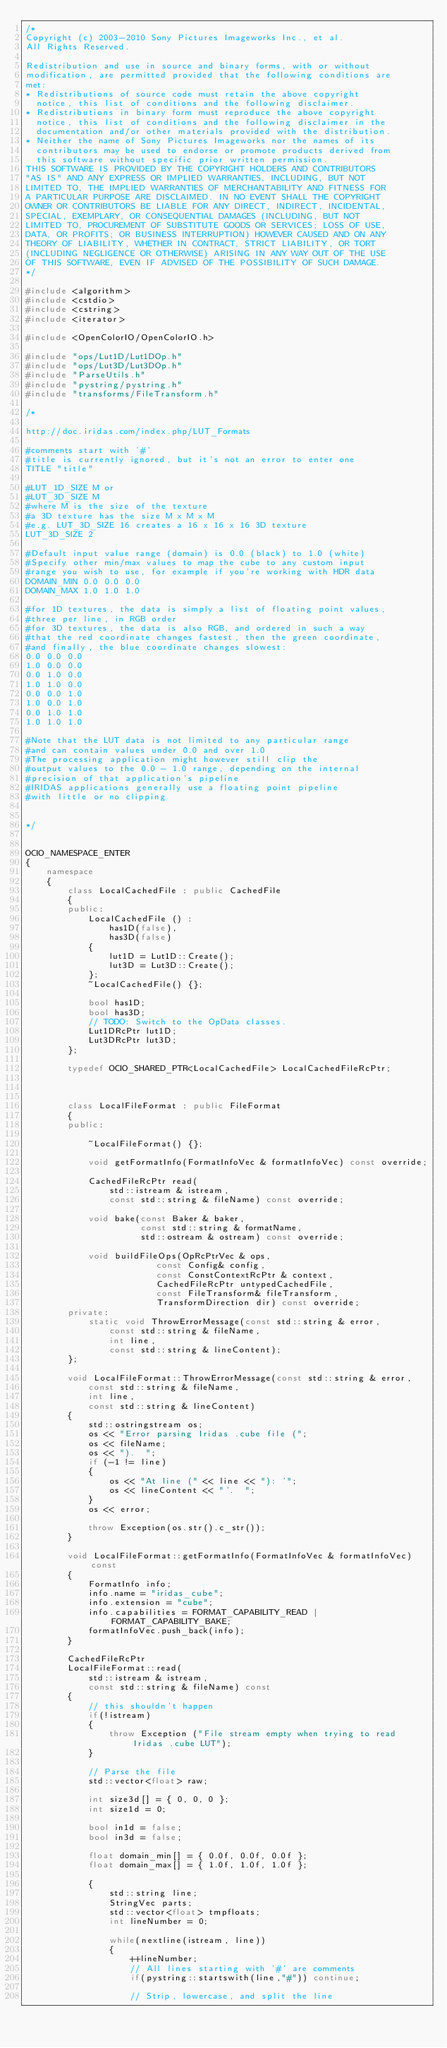<code> <loc_0><loc_0><loc_500><loc_500><_C++_>/*
Copyright (c) 2003-2010 Sony Pictures Imageworks Inc., et al.
All Rights Reserved.

Redistribution and use in source and binary forms, with or without
modification, are permitted provided that the following conditions are
met:
* Redistributions of source code must retain the above copyright
  notice, this list of conditions and the following disclaimer.
* Redistributions in binary form must reproduce the above copyright
  notice, this list of conditions and the following disclaimer in the
  documentation and/or other materials provided with the distribution.
* Neither the name of Sony Pictures Imageworks nor the names of its
  contributors may be used to endorse or promote products derived from
  this software without specific prior written permission.
THIS SOFTWARE IS PROVIDED BY THE COPYRIGHT HOLDERS AND CONTRIBUTORS
"AS IS" AND ANY EXPRESS OR IMPLIED WARRANTIES, INCLUDING, BUT NOT
LIMITED TO, THE IMPLIED WARRANTIES OF MERCHANTABILITY AND FITNESS FOR
A PARTICULAR PURPOSE ARE DISCLAIMED. IN NO EVENT SHALL THE COPYRIGHT
OWNER OR CONTRIBUTORS BE LIABLE FOR ANY DIRECT, INDIRECT, INCIDENTAL,
SPECIAL, EXEMPLARY, OR CONSEQUENTIAL DAMAGES (INCLUDING, BUT NOT
LIMITED TO, PROCUREMENT OF SUBSTITUTE GOODS OR SERVICES; LOSS OF USE,
DATA, OR PROFITS; OR BUSINESS INTERRUPTION) HOWEVER CAUSED AND ON ANY
THEORY OF LIABILITY, WHETHER IN CONTRACT, STRICT LIABILITY, OR TORT
(INCLUDING NEGLIGENCE OR OTHERWISE) ARISING IN ANY WAY OUT OF THE USE
OF THIS SOFTWARE, EVEN IF ADVISED OF THE POSSIBILITY OF SUCH DAMAGE.
*/

#include <algorithm>
#include <cstdio>
#include <cstring>
#include <iterator>

#include <OpenColorIO/OpenColorIO.h>

#include "ops/Lut1D/Lut1DOp.h"
#include "ops/Lut3D/Lut3DOp.h"
#include "ParseUtils.h"
#include "pystring/pystring.h"
#include "transforms/FileTransform.h"

/*

http://doc.iridas.com/index.php/LUT_Formats

#comments start with '#'
#title is currently ignored, but it's not an error to enter one
TITLE "title"

#LUT_1D_SIZE M or
#LUT_3D_SIZE M
#where M is the size of the texture
#a 3D texture has the size M x M x M
#e.g. LUT_3D_SIZE 16 creates a 16 x 16 x 16 3D texture
LUT_3D_SIZE 2 

#Default input value range (domain) is 0.0 (black) to 1.0 (white)
#Specify other min/max values to map the cube to any custom input
#range you wish to use, for example if you're working with HDR data
DOMAIN_MIN 0.0 0.0 0.0
DOMAIN_MAX 1.0 1.0 1.0

#for 1D textures, the data is simply a list of floating point values,
#three per line, in RGB order
#for 3D textures, the data is also RGB, and ordered in such a way
#that the red coordinate changes fastest, then the green coordinate,
#and finally, the blue coordinate changes slowest:
0.0 0.0 0.0
1.0 0.0 0.0
0.0 1.0 0.0
1.0 1.0 0.0
0.0 0.0 1.0
1.0 0.0 1.0
0.0 1.0 1.0
1.0 1.0 1.0

#Note that the LUT data is not limited to any particular range
#and can contain values under 0.0 and over 1.0
#The processing application might however still clip the
#output values to the 0.0 - 1.0 range, depending on the internal
#precision of that application's pipeline
#IRIDAS applications generally use a floating point pipeline
#with little or no clipping


*/


OCIO_NAMESPACE_ENTER
{
    namespace
    {
        class LocalCachedFile : public CachedFile
        {
        public:
            LocalCachedFile () : 
                has1D(false),
                has3D(false)
            {
                lut1D = Lut1D::Create();
                lut3D = Lut3D::Create();
            };
            ~LocalCachedFile() {};
            
            bool has1D;
            bool has3D;
            // TODO: Switch to the OpData classes.
            Lut1DRcPtr lut1D;
            Lut3DRcPtr lut3D;
        };
        
        typedef OCIO_SHARED_PTR<LocalCachedFile> LocalCachedFileRcPtr;
        
        
        
        class LocalFileFormat : public FileFormat
        {
        public:
            
            ~LocalFileFormat() {};
            
            void getFormatInfo(FormatInfoVec & formatInfoVec) const override;
            
            CachedFileRcPtr read(
                std::istream & istream,
                const std::string & fileName) const override;
            
            void bake(const Baker & baker,
                      const std::string & formatName,
                      std::ostream & ostream) const override;
            
            void buildFileOps(OpRcPtrVec & ops,
                         const Config& config,
                         const ConstContextRcPtr & context,
                         CachedFileRcPtr untypedCachedFile,
                         const FileTransform& fileTransform,
                         TransformDirection dir) const override;
        private:
            static void ThrowErrorMessage(const std::string & error,
                const std::string & fileName,
                int line,
                const std::string & lineContent);
        };
        
        void LocalFileFormat::ThrowErrorMessage(const std::string & error,
            const std::string & fileName,
            int line,
            const std::string & lineContent)
        {
            std::ostringstream os;
            os << "Error parsing Iridas .cube file (";
            os << fileName;
            os << ").  ";
            if (-1 != line)
            {
                os << "At line (" << line << "): '";
                os << lineContent << "'.  ";
            }
            os << error;

            throw Exception(os.str().c_str());
        }

        void LocalFileFormat::getFormatInfo(FormatInfoVec & formatInfoVec) const
        {
            FormatInfo info;
            info.name = "iridas_cube";
            info.extension = "cube";
            info.capabilities = FORMAT_CAPABILITY_READ | FORMAT_CAPABILITY_BAKE;
            formatInfoVec.push_back(info);
        }
        
        CachedFileRcPtr
        LocalFileFormat::read(
            std::istream & istream,
            const std::string & fileName) const
        {
            // this shouldn't happen
            if(!istream)
            {
                throw Exception ("File stream empty when trying to read Iridas .cube LUT");
            }
            
            // Parse the file
            std::vector<float> raw;
            
            int size3d[] = { 0, 0, 0 };
            int size1d = 0;
            
            bool in1d = false;
            bool in3d = false;
            
            float domain_min[] = { 0.0f, 0.0f, 0.0f };
            float domain_max[] = { 1.0f, 1.0f, 1.0f };
            
            {
                std::string line;
                StringVec parts;
                std::vector<float> tmpfloats;
                int lineNumber = 0;
                
                while(nextline(istream, line))
                {
                    ++lineNumber;
                    // All lines starting with '#' are comments
                    if(pystring::startswith(line,"#")) continue;
                    
                    // Strip, lowercase, and split the line</code> 